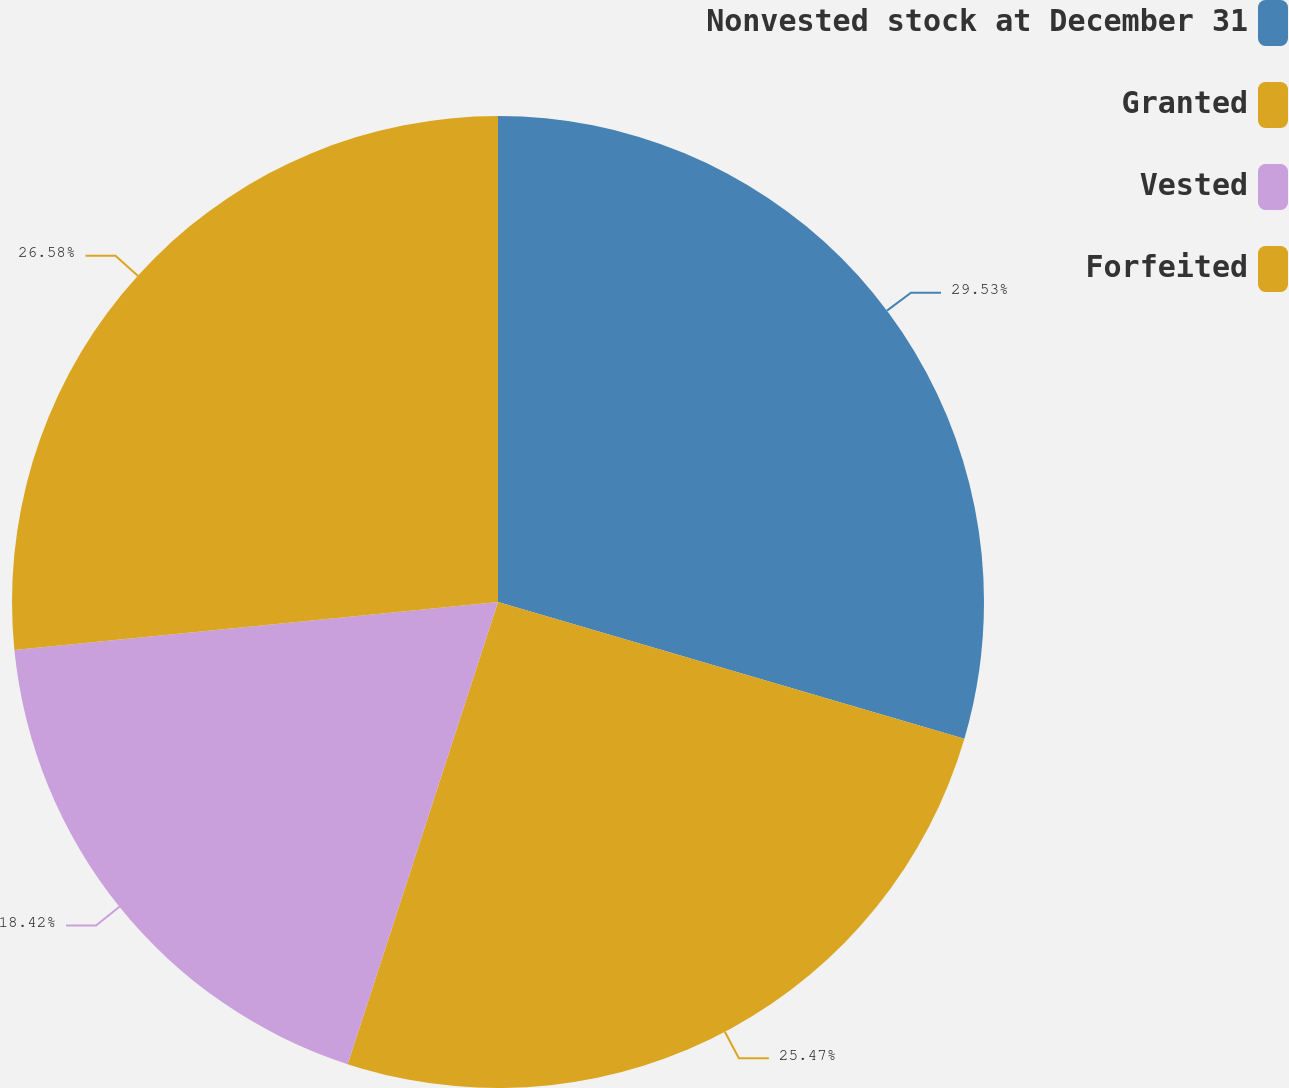<chart> <loc_0><loc_0><loc_500><loc_500><pie_chart><fcel>Nonvested stock at December 31<fcel>Granted<fcel>Vested<fcel>Forfeited<nl><fcel>29.54%<fcel>25.47%<fcel>18.42%<fcel>26.58%<nl></chart> 